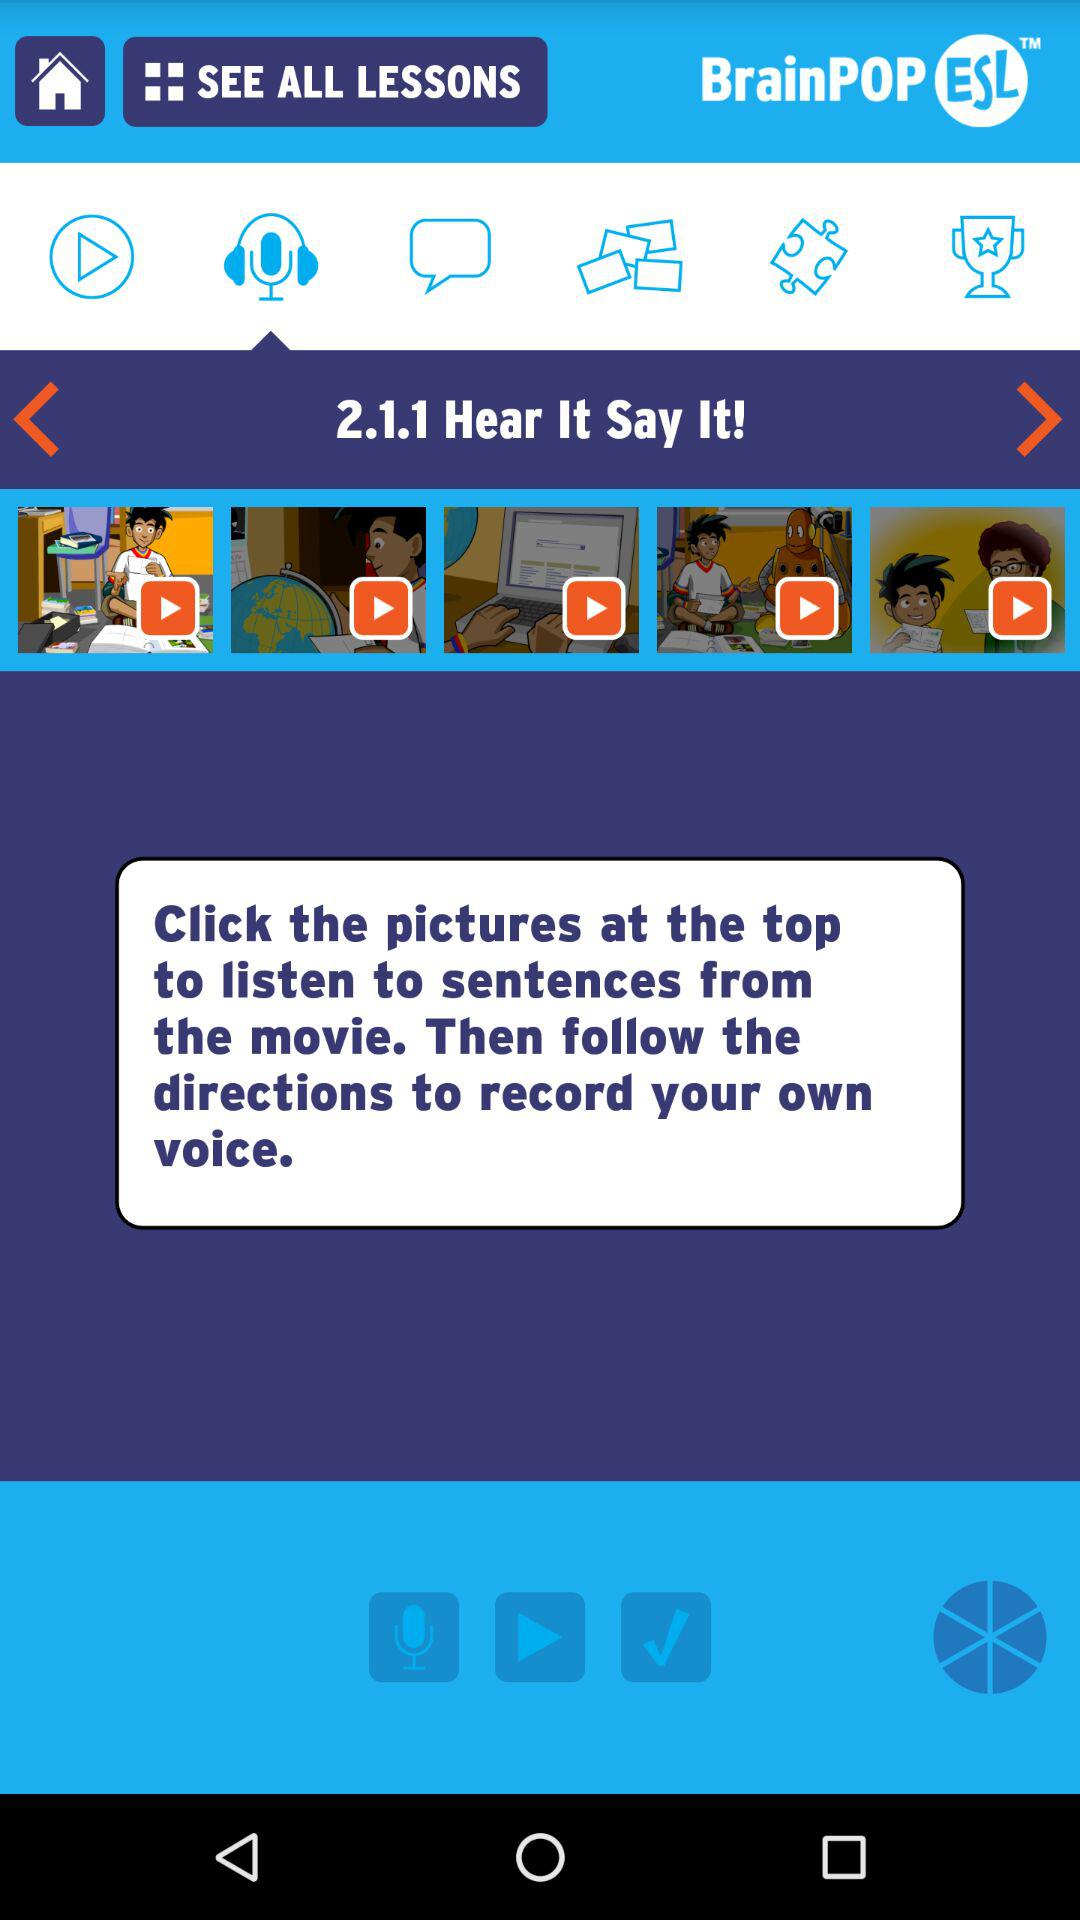What is the name of the application? The name of the application is "BrainPOP ESL". 